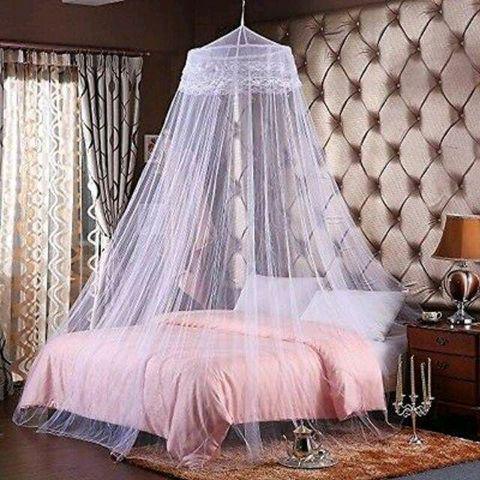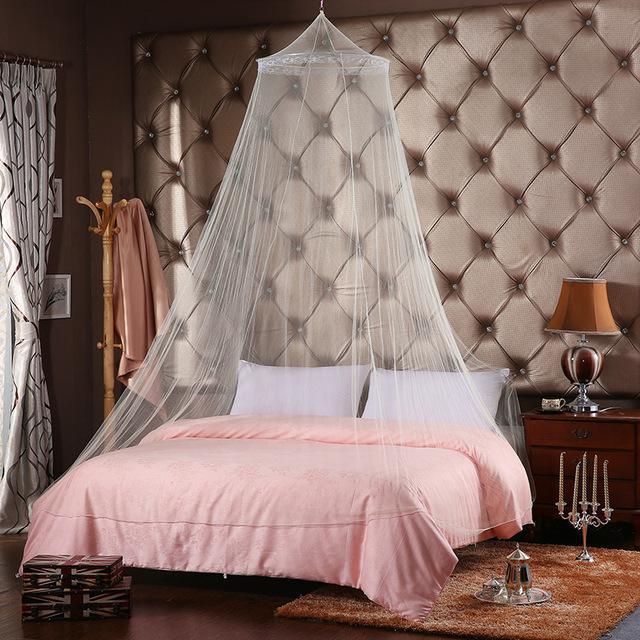The first image is the image on the left, the second image is the image on the right. For the images shown, is this caption "Exactly one bed has a round canopy." true? Answer yes or no. No. The first image is the image on the left, the second image is the image on the right. For the images displayed, is the sentence "Two or more lamp shades are visible." factually correct? Answer yes or no. Yes. 